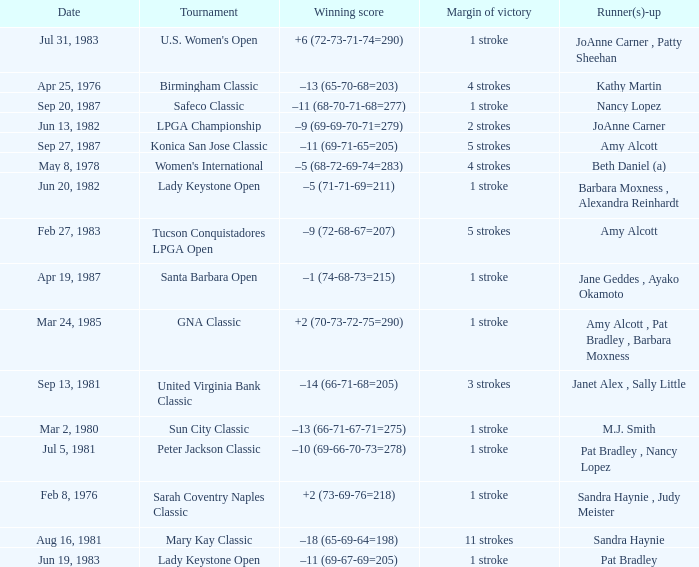What is the tournament when the winning score is –9 (69-69-70-71=279)? LPGA Championship. 